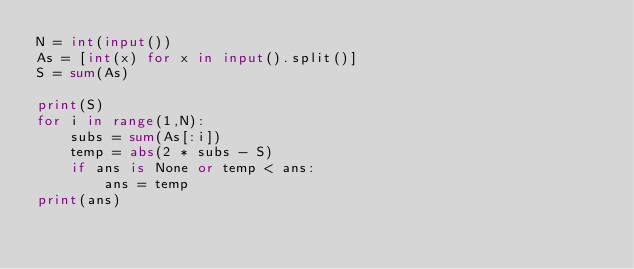<code> <loc_0><loc_0><loc_500><loc_500><_Python_>N = int(input())
As = [int(x) for x in input().split()]
S = sum(As)

print(S)
for i in range(1,N):
    subs = sum(As[:i])
    temp = abs(2 * subs - S)
    if ans is None or temp < ans:
        ans = temp
print(ans)
</code> 